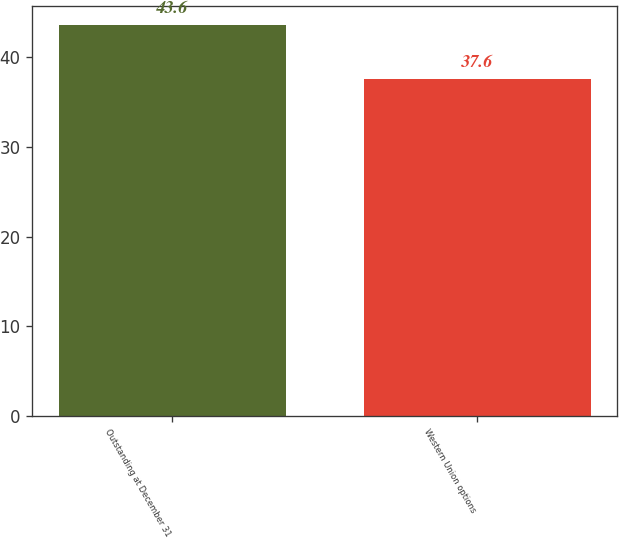<chart> <loc_0><loc_0><loc_500><loc_500><bar_chart><fcel>Outstanding at December 31<fcel>Western Union options<nl><fcel>43.6<fcel>37.6<nl></chart> 